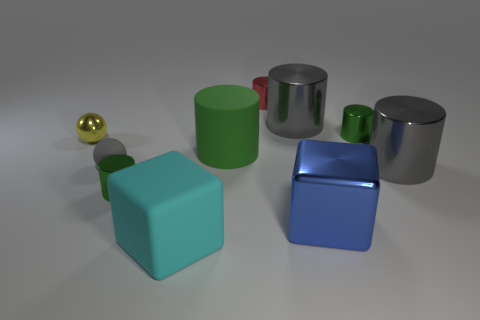How is the lighting arranged in this scene? The lighting in the scene seems to be coming from above, possibly from multiple light sources given the multiple shadows each object casts. The soft shadows and the lack of sharp contrasts suggest the light sources are diffused, creating an even illumination across the entire scene. 